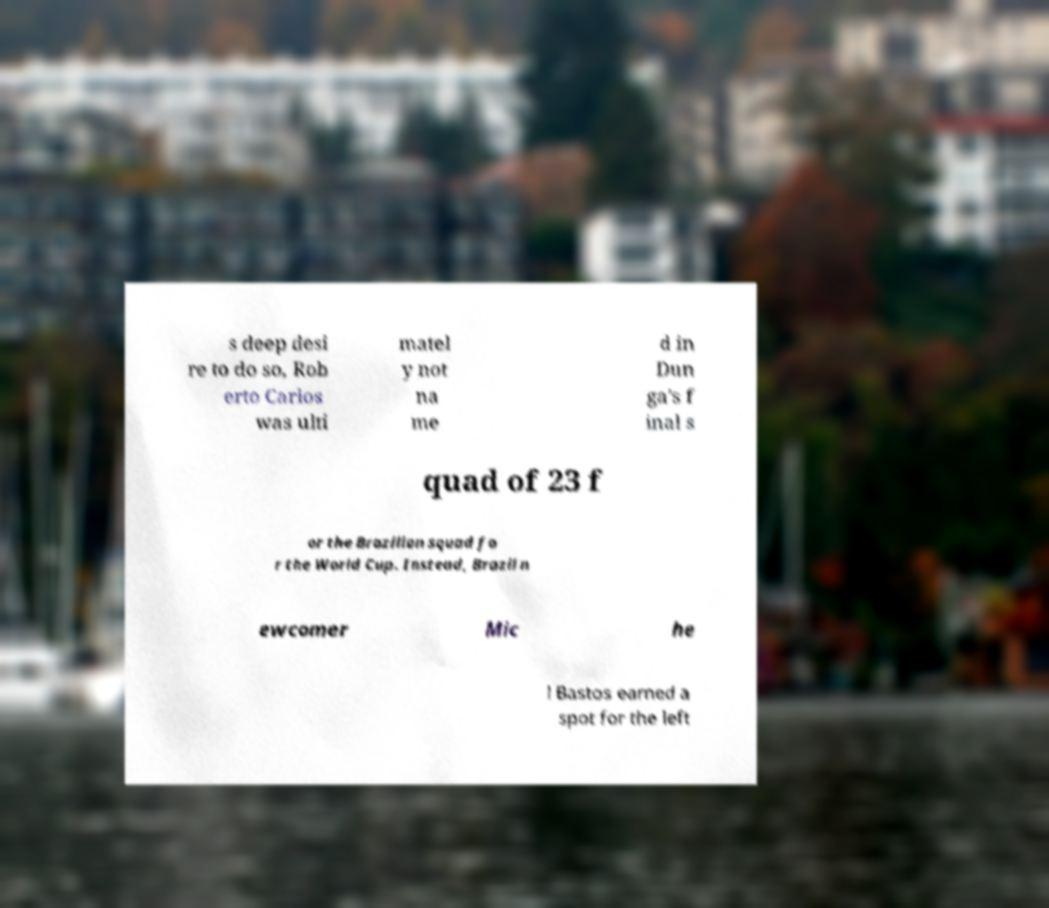Can you read and provide the text displayed in the image?This photo seems to have some interesting text. Can you extract and type it out for me? s deep desi re to do so, Rob erto Carlos was ulti matel y not na me d in Dun ga's f inal s quad of 23 f or the Brazilian squad fo r the World Cup. Instead, Brazil n ewcomer Mic he l Bastos earned a spot for the left 